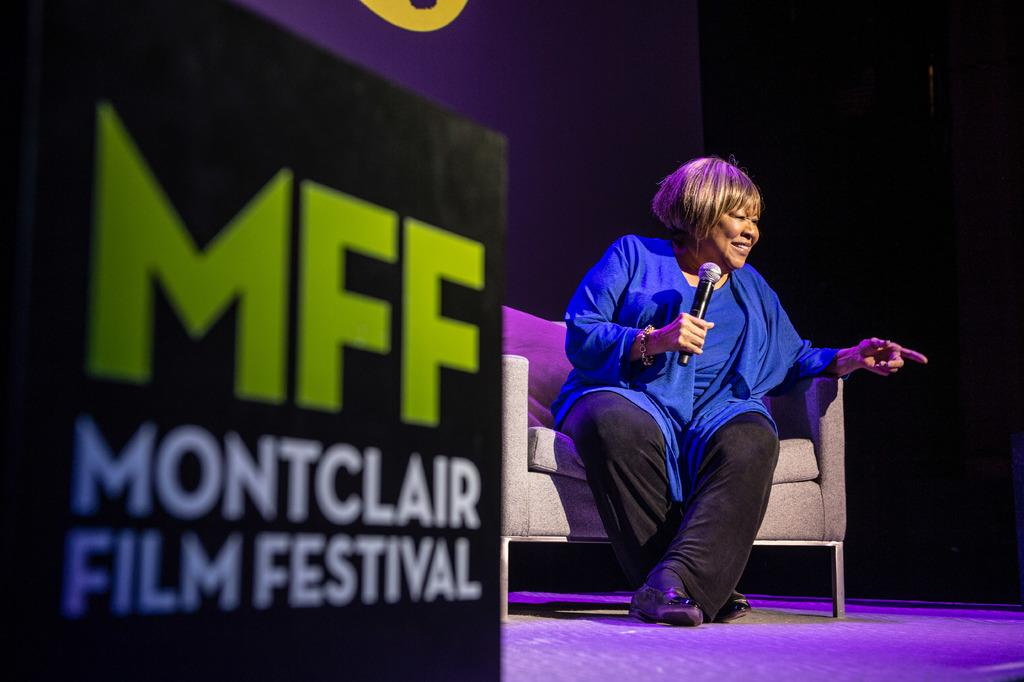What is the person in the image doing? The person is sitting on a couch in the image. What is the person holding in the image? The person is holding an object in the image. Can you describe the object that the person is holding? Unfortunately, the facts provided do not give enough information to describe the object the person is holding. What is present at the left side of the image? There is some text on an object at the left side of the image. What type of quiver is visible on the army base in the image? There is no army base or quiver present in the image. 